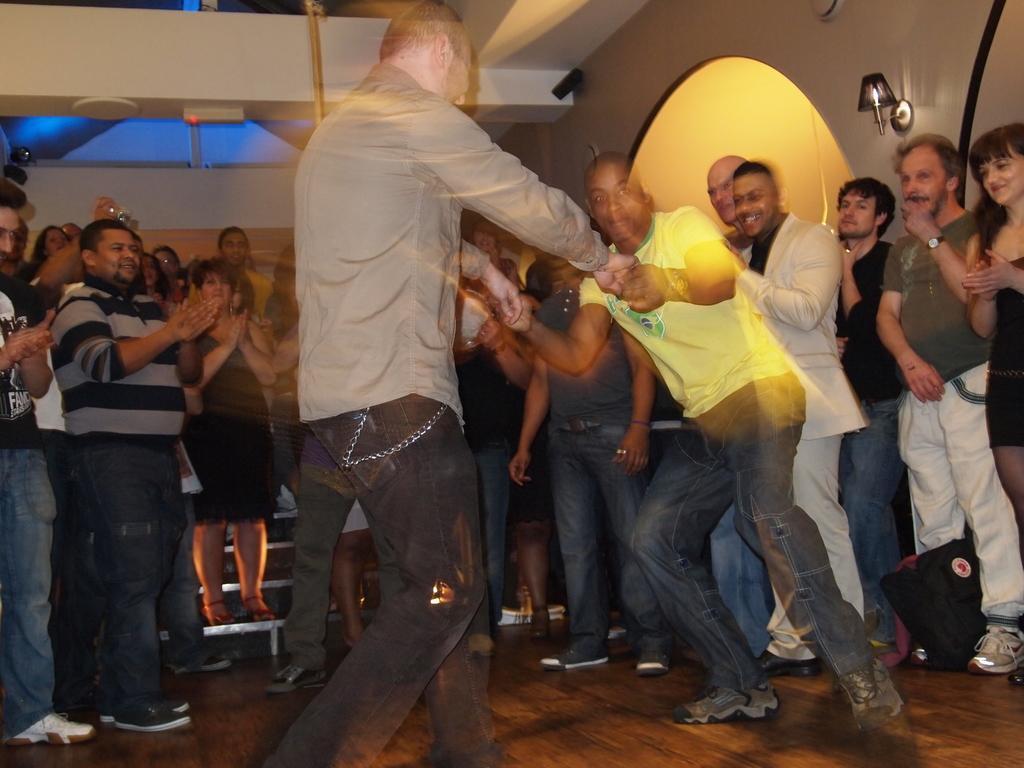How would you summarize this image in a sentence or two? In this picture we can see there are two men dancing on the floor. Behind the two men, there is a group of people standing. At the top right corner of the image, there is a light attached to a wall. 